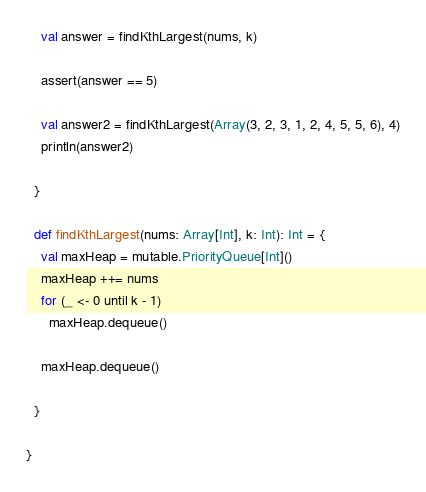Convert code to text. <code><loc_0><loc_0><loc_500><loc_500><_Scala_>    val answer = findKthLargest(nums, k)

    assert(answer == 5)

    val answer2 = findKthLargest(Array(3, 2, 3, 1, 2, 4, 5, 5, 6), 4)
    println(answer2)

  }

  def findKthLargest(nums: Array[Int], k: Int): Int = {
    val maxHeap = mutable.PriorityQueue[Int]()
    maxHeap ++= nums
    for (_ <- 0 until k - 1)
      maxHeap.dequeue()

    maxHeap.dequeue()

  }

}
</code> 